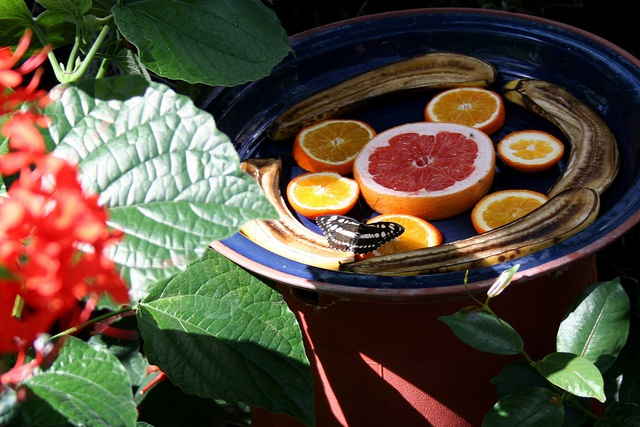Describe the objects in this image and their specific colors. I can see orange in olive, brown, maroon, and darkgray tones, banana in olive, black, maroon, and gray tones, banana in olive, black, maroon, and gray tones, banana in olive, black, maroon, and gray tones, and banana in olive, ivory, khaki, tan, and black tones in this image. 